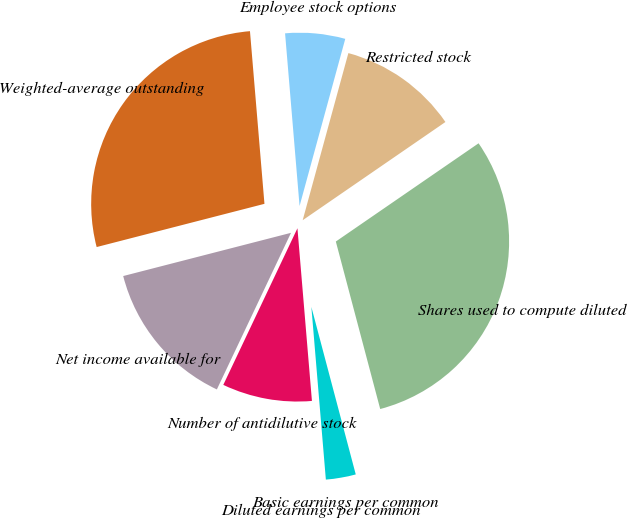Convert chart. <chart><loc_0><loc_0><loc_500><loc_500><pie_chart><fcel>Net income available for<fcel>Weighted-average outstanding<fcel>Employee stock options<fcel>Restricted stock<fcel>Shares used to compute diluted<fcel>Basic earnings per common<fcel>Diluted earnings per common<fcel>Number of antidilutive stock<nl><fcel>13.95%<fcel>27.68%<fcel>5.58%<fcel>11.16%<fcel>30.47%<fcel>2.79%<fcel>0.0%<fcel>8.37%<nl></chart> 